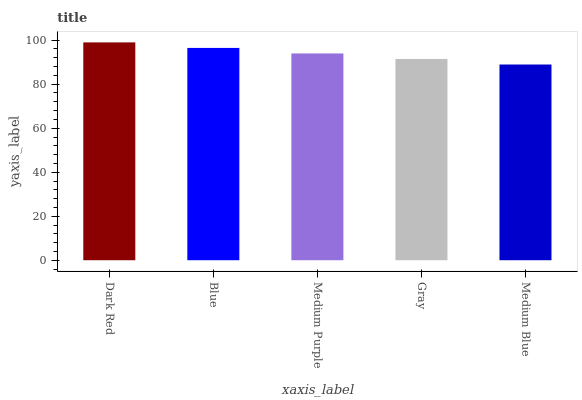Is Medium Blue the minimum?
Answer yes or no. Yes. Is Dark Red the maximum?
Answer yes or no. Yes. Is Blue the minimum?
Answer yes or no. No. Is Blue the maximum?
Answer yes or no. No. Is Dark Red greater than Blue?
Answer yes or no. Yes. Is Blue less than Dark Red?
Answer yes or no. Yes. Is Blue greater than Dark Red?
Answer yes or no. No. Is Dark Red less than Blue?
Answer yes or no. No. Is Medium Purple the high median?
Answer yes or no. Yes. Is Medium Purple the low median?
Answer yes or no. Yes. Is Medium Blue the high median?
Answer yes or no. No. Is Medium Blue the low median?
Answer yes or no. No. 